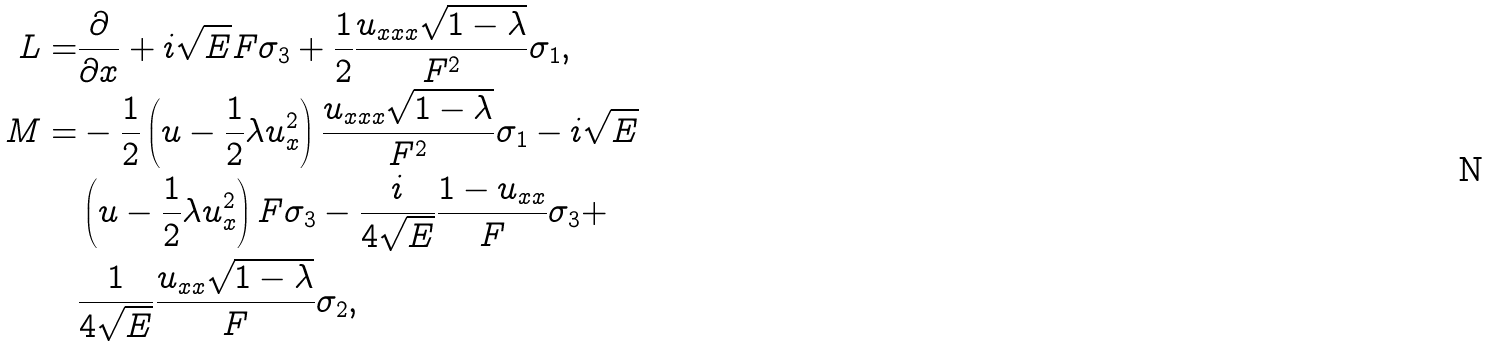Convert formula to latex. <formula><loc_0><loc_0><loc_500><loc_500>L = & \frac { \partial } { \partial x } + i \sqrt { E } F \sigma _ { 3 } + \frac { 1 } { 2 } \frac { u _ { x x x } \sqrt { 1 - \lambda } } { F ^ { 2 } } \sigma _ { 1 } , \\ M = & - \frac { 1 } { 2 } \left ( u - \frac { 1 } { 2 } \lambda u ^ { 2 } _ { x } \right ) \frac { u _ { x x x } \sqrt { 1 - \lambda } } { F ^ { 2 } } \sigma _ { 1 } - i \sqrt { E } \\ & \left ( u - \frac { 1 } { 2 } \lambda u ^ { 2 } _ { x } \right ) F \sigma _ { 3 } - \frac { i } { 4 \sqrt { E } } \frac { 1 - u _ { x x } } { F } \sigma _ { 3 } + \\ & \frac { 1 } { 4 \sqrt { E } } \frac { u _ { x x } \sqrt { 1 - \lambda } } { F } \sigma _ { 2 } ,</formula> 